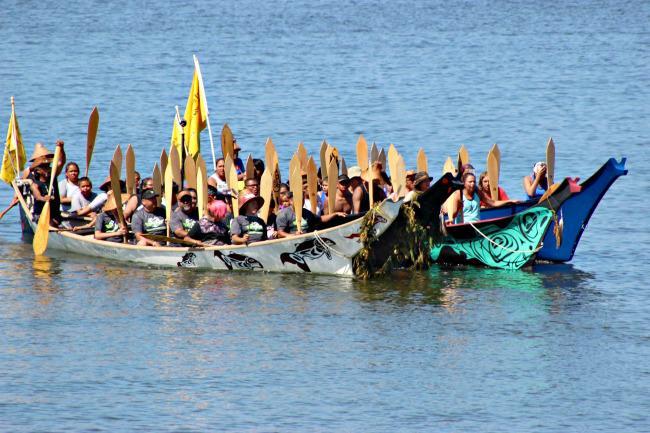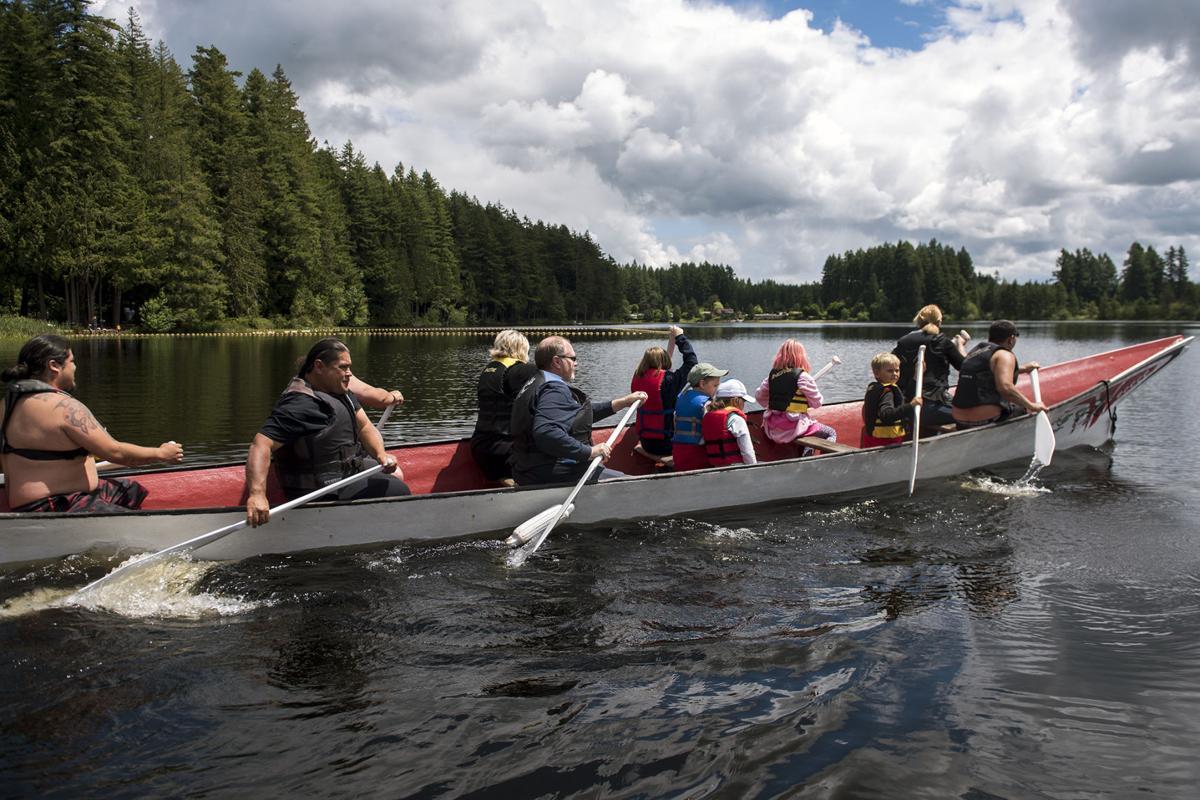The first image is the image on the left, the second image is the image on the right. Considering the images on both sides, is "An image shows the tips of at least two reddish-brown boats that are pulled to shore and overlooking the water." valid? Answer yes or no. No. The first image is the image on the left, the second image is the image on the right. For the images shown, is this caption "In at least one image there are at least three empty boats." true? Answer yes or no. No. 